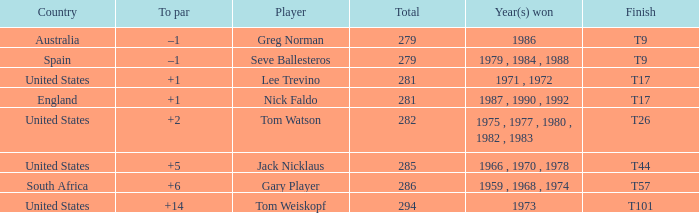Which country had a total of 282? United States. 